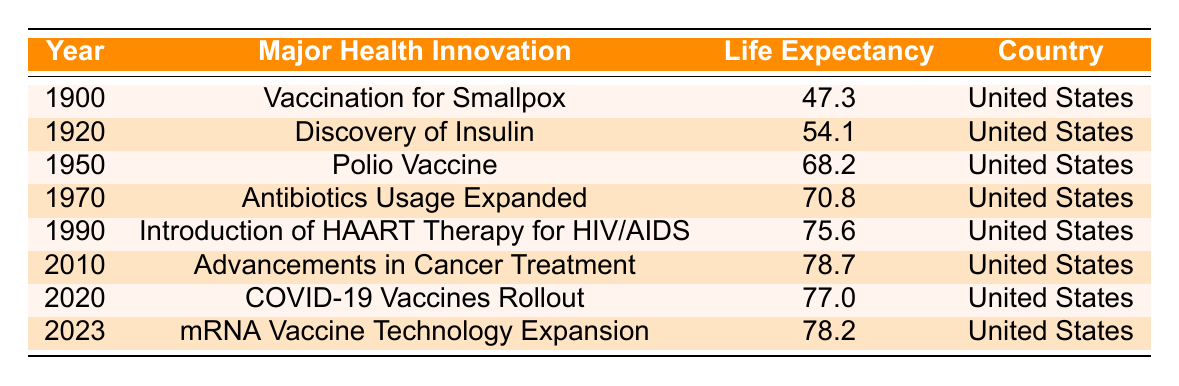What was the life expectancy in 1900? The table shows that the life expectancy for the year 1900 was recorded as 47.3 years in the United States.
Answer: 47.3 Which health innovation occurred in 1990? According to the table, the major health innovation in 1990 was the introduction of HAART therapy for HIV/AIDS.
Answer: Introduction of HAART therapy for HIV/AIDS What was the increase in life expectancy from 1950 to 1970? In 1950, life expectancy was 68.2 years and in 1970 it was 70.8 years. The increase is calculated as 70.8 - 68.2 = 2.6 years.
Answer: 2.6 years Did life expectancy ever decrease from one health innovation year to the next? By reviewing the table, we see that from 2010 (78.7 years) to 2020 (77.0 years) there was a decline in life expectancy, indicating a decrease.
Answer: Yes What is the average life expectancy from 1900 to 2023? To find the average, we need to sum the life expectancies (47.3 + 54.1 + 68.2 + 70.8 + 75.6 + 78.7 + 77.0 + 78.2) which equals 501.9. There are 8 data points, so the average is 501.9 / 8 = 62.74.
Answer: 62.74 What was the life expectancy after the rollout of COVID-19 vaccines? The table indicates that the life expectancy after the rollout of COVID-19 vaccines in 2020 was 77.0 years.
Answer: 77.0 Was the introduction of the Polio vaccine the first major health innovation listed? The first major health innovation listed in the table is the vaccination for smallpox in 1900, which predates the Polio vaccine introduced in 1950.
Answer: No What is the difference in life expectancy between the years 2010 and 2023? In 2010, life expectancy was 78.7 years and in 2023 it is 78.2 years. The difference is 78.2 - 78.7 = -0.5 years, indicating a slight decline.
Answer: -0.5 years 